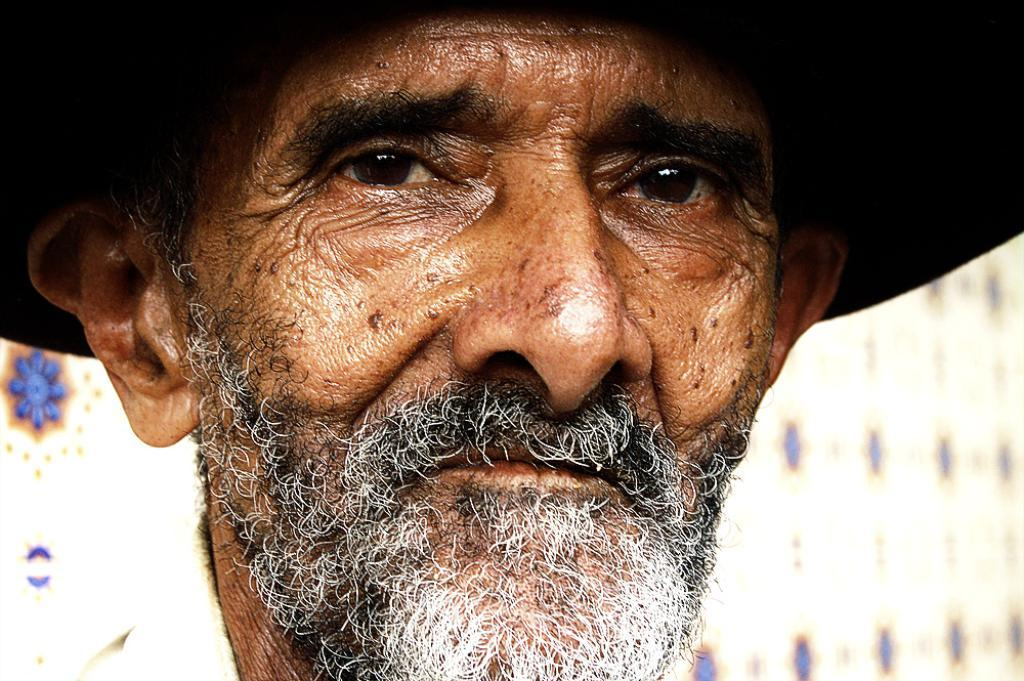What is the main subject of the image? There is an old man in the image. What is the old man doing in the image? The old man is looking forward. Can you describe the background of the image? The background of the image is blurred. What type of smoke can be seen coming from the machine in the image? There is no machine or smoke present in the image; it features an old man looking forward with a blurred background. 